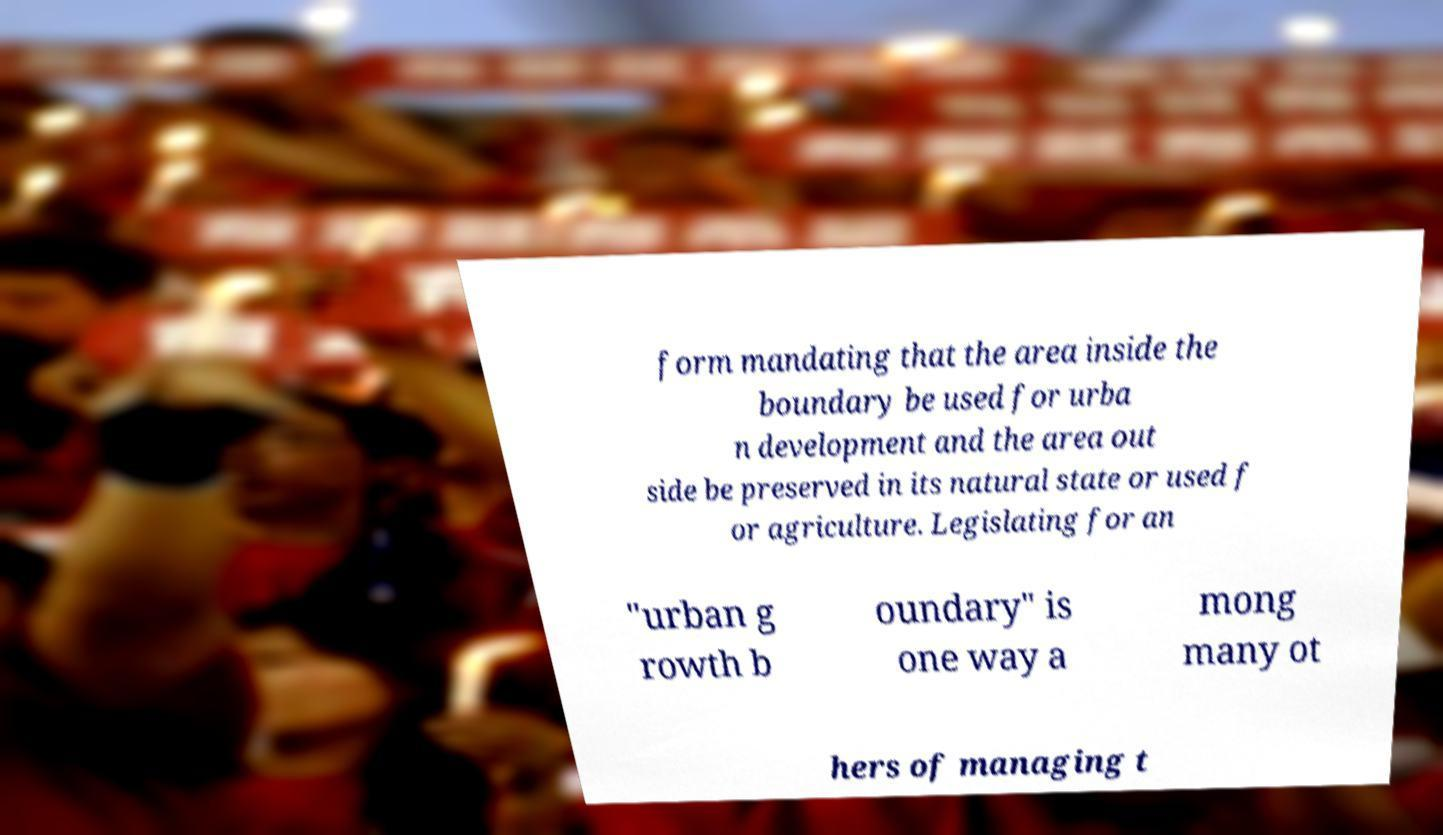Could you extract and type out the text from this image? form mandating that the area inside the boundary be used for urba n development and the area out side be preserved in its natural state or used f or agriculture. Legislating for an "urban g rowth b oundary" is one way a mong many ot hers of managing t 